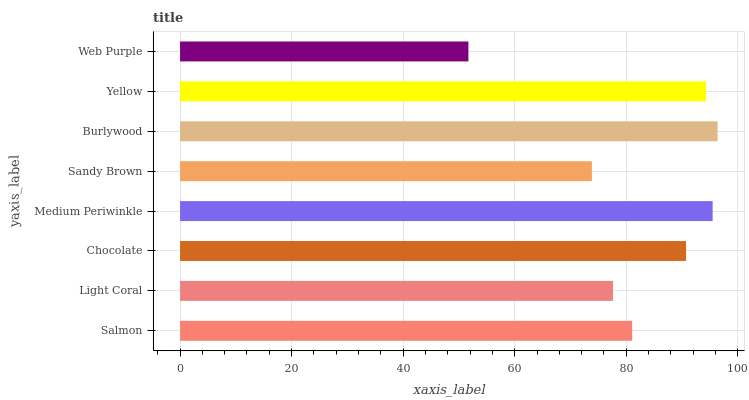Is Web Purple the minimum?
Answer yes or no. Yes. Is Burlywood the maximum?
Answer yes or no. Yes. Is Light Coral the minimum?
Answer yes or no. No. Is Light Coral the maximum?
Answer yes or no. No. Is Salmon greater than Light Coral?
Answer yes or no. Yes. Is Light Coral less than Salmon?
Answer yes or no. Yes. Is Light Coral greater than Salmon?
Answer yes or no. No. Is Salmon less than Light Coral?
Answer yes or no. No. Is Chocolate the high median?
Answer yes or no. Yes. Is Salmon the low median?
Answer yes or no. Yes. Is Web Purple the high median?
Answer yes or no. No. Is Medium Periwinkle the low median?
Answer yes or no. No. 